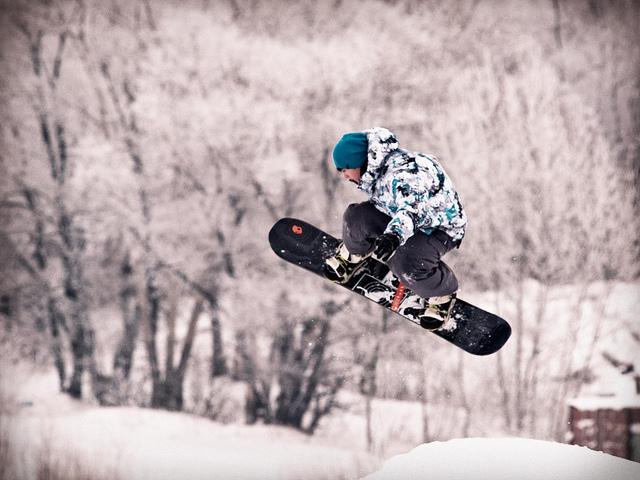How many trees are in the background?
Be succinct. 20. What is the man standing on?
Write a very short answer. Snowboard. Do you think this person will land properly?
Be succinct. Yes. 